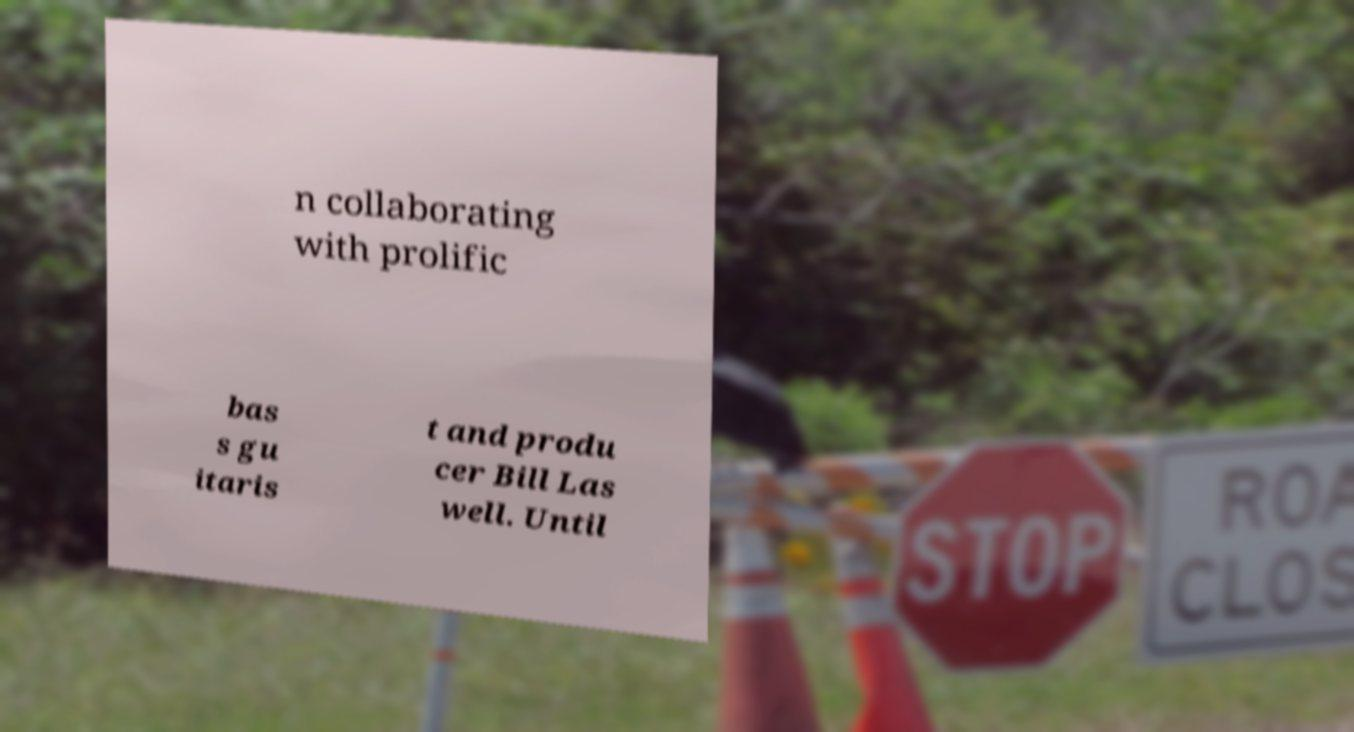For documentation purposes, I need the text within this image transcribed. Could you provide that? n collaborating with prolific bas s gu itaris t and produ cer Bill Las well. Until 